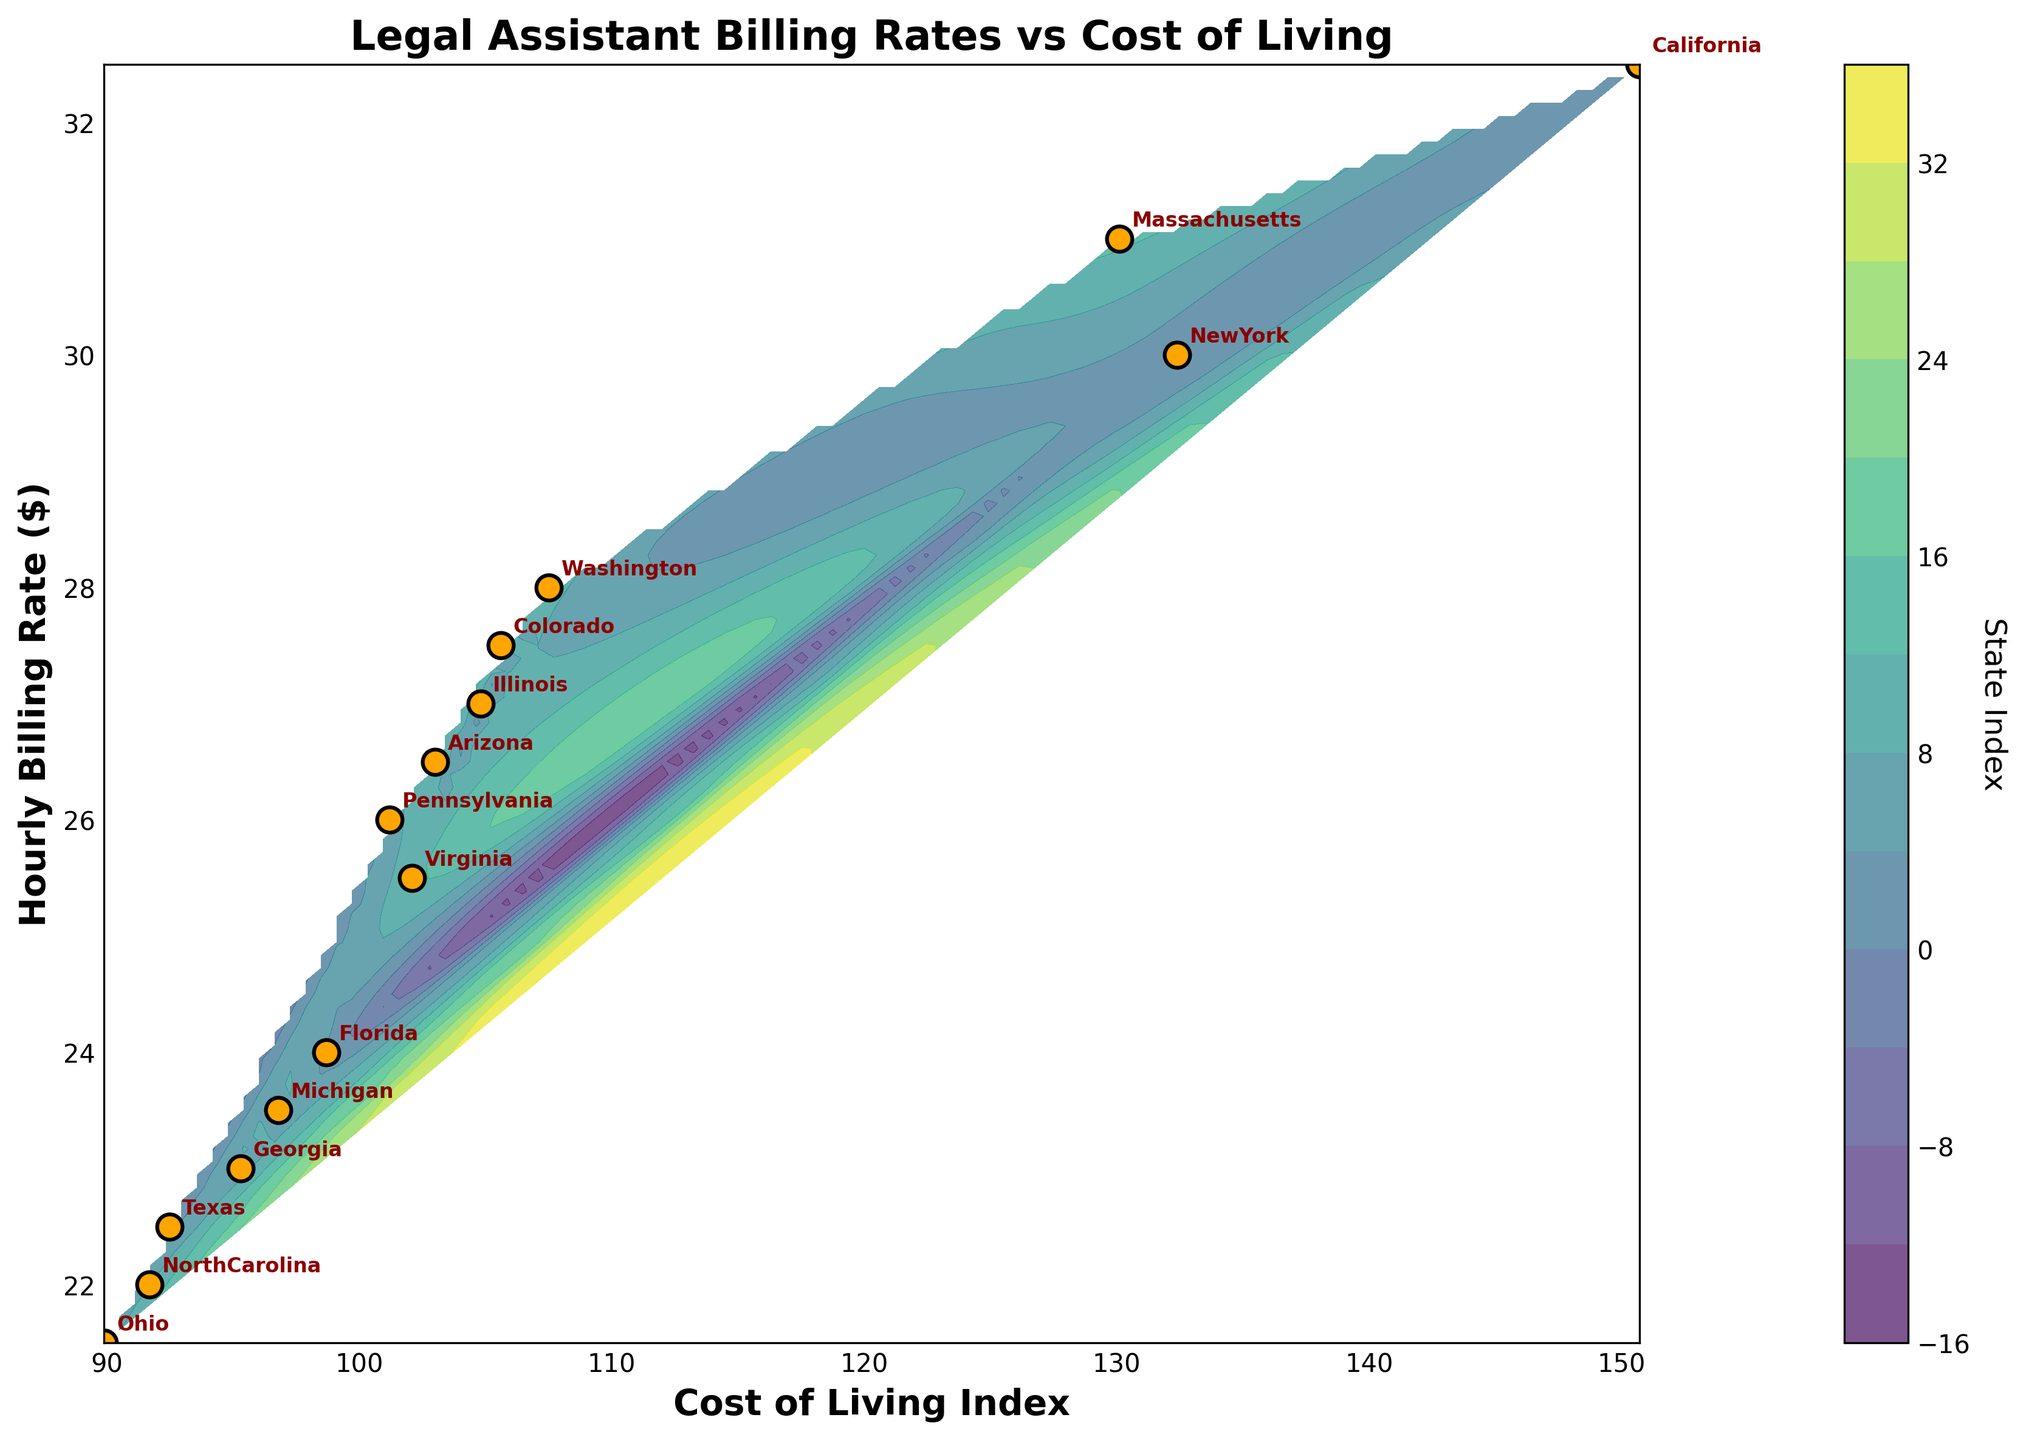What is the title of the plot? The title is usually displayed at the top of the figure. In this case, it reads "Legal Assistant Billing Rates vs Cost of Living".
Answer: Legal Assistant Billing Rates vs Cost of Living How many states are represented in the plot? Each state in the dataset is labeled on the plot. Counting these labeled points will tell us the number of states.
Answer: 15 What is the cost of living index for California, and how does it compare to Texas? Locate California and Texas labels on the x-axis. California's index is around 150.7 and Texas’s is around 92.5. California has a higher cost of living index.
Answer: California: 150.7, Texas: 92.5; California has a higher cost of living index Which state has the highest hourly billing rate? Check the plot for the highest point on the y-axis and find the corresponding state label. California appears to have the highest rate at around $32.5.
Answer: California Is there any visible relationship between billing rates and cost of living indices? Observing the scatter plot, states with higher hourly billing rates tend to have higher cost of living indices, indicating a positive correlation.
Answer: Positive correlation What color is used to represent the contour lines? Contour lines in the figure are shaded, and they vary in color according to a color gradient. The plot uses a viridis color map.
Answer: Viridis (gradient from yellow to purple) Which state has the lowest hourly billing rate, and what is it? Identify the lowest point on the y-axis and find the corresponding state label. Ohio has the lowest billing rate at around $21.5.
Answer: Ohio, $21.5 Compare the hourly billing rates between Washington and Florida. Locate the positions of these states' labels on the y-axis. Washington has a billing rate of $28.0 and Florida has a rate of $24.0, so Washington's rate is higher.
Answer: Washington: $28.0, Florida: $24.0; Washington's rate is higher How does the hourly billing rate in Massachusetts compare to New York? Find Massachusetts and New York on the y-axis. Massachusetts has a billing rate of $31.0, while New York has $30.0, making Massachusetts’ rate higher.
Answer: Massachusetts: $31.0, New York: $30.0; Massachusetts’ rate is higher What is the cost of living index for states with hourly billing rates above $27? Identify states with rates above $27 (California, New York, Washington, Massachusetts, Colorado, Illinois). Their indices are: California (150.7), New York (132.4), Washington (107.5), Massachusetts (130.1), Colorado (105.6), Illinois (104.8).
Answer: California: 150.7, New York: 132.4, Washington: 107.5, Massachusetts: 130.1, Colorado: 105.6, Illinois: 104.8 